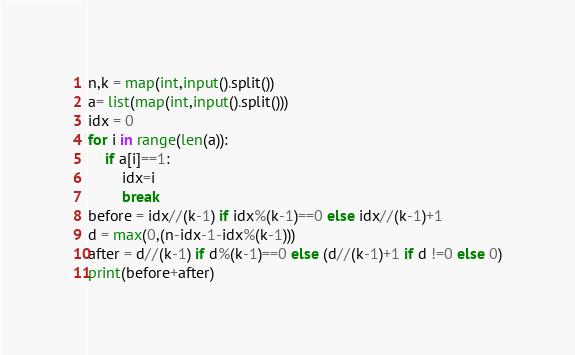<code> <loc_0><loc_0><loc_500><loc_500><_Python_>n,k = map(int,input().split())
a= list(map(int,input().split()))
idx = 0
for i in range(len(a)):
    if a[i]==1:
        idx=i
        break
before = idx//(k-1) if idx%(k-1)==0 else idx//(k-1)+1
d = max(0,(n-idx-1-idx%(k-1)))
after = d//(k-1) if d%(k-1)==0 else (d//(k-1)+1 if d !=0 else 0)
print(before+after)</code> 